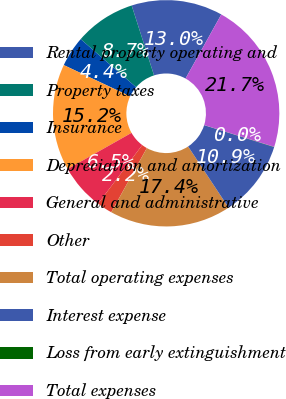Convert chart. <chart><loc_0><loc_0><loc_500><loc_500><pie_chart><fcel>Rental property operating and<fcel>Property taxes<fcel>Insurance<fcel>Depreciation and amortization<fcel>General and administrative<fcel>Other<fcel>Total operating expenses<fcel>Interest expense<fcel>Loss from early extinguishment<fcel>Total expenses<nl><fcel>13.03%<fcel>8.7%<fcel>4.37%<fcel>15.19%<fcel>6.54%<fcel>2.21%<fcel>17.36%<fcel>10.87%<fcel>0.04%<fcel>21.69%<nl></chart> 